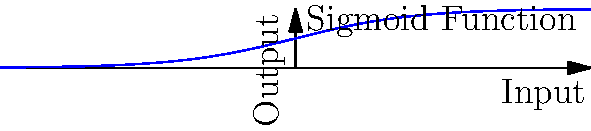Given the input-output graph of a deep learning model's activation function, identify the function and explain its significance in neural networks. Additionally, calculate the output value when the input is 0. To solve this problem, let's follow these steps:

1. Identify the function:
   The graph shows an S-shaped curve that asymptotically approaches 0 as x approaches negative infinity and 1 as x approaches positive infinity. This is characteristic of the sigmoid function.

2. The sigmoid function is defined as:
   $$ f(x) = \frac{1}{1 + e^{-x}} $$

3. Significance in neural networks:
   - The sigmoid function is commonly used as an activation function in neural networks.
   - It maps any input value to an output between 0 and 1, which can be interpreted as a probability.
   - It introduces non-linearity into the network, allowing it to learn complex patterns.
   - However, it suffers from the vanishing gradient problem for very large or small inputs.

4. Calculate the output when input is 0:
   $$ f(0) = \frac{1}{1 + e^{-0}} = \frac{1}{1 + 1} = \frac{1}{2} = 0.5 $$

This can also be visually confirmed from the graph, where the curve passes through the point (0, 0.5).
Answer: Sigmoid function; output at x=0 is 0.5 